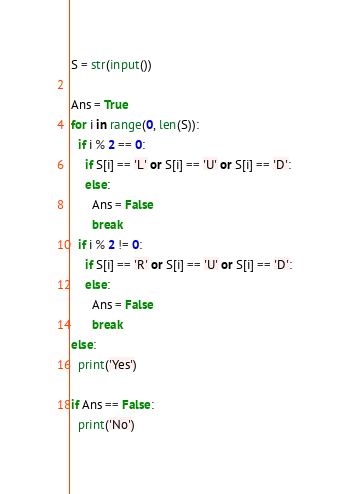<code> <loc_0><loc_0><loc_500><loc_500><_Python_>S = str(input())

Ans = True
for i in range(0, len(S)):
  if i % 2 == 0:
    if S[i] == 'L' or S[i] == 'U' or S[i] == 'D':
    else:
      Ans = False
      break
  if i % 2 != 0:
    if S[i] == 'R' or S[i] == 'U' or S[i] == 'D':
    else:
      Ans = False
      break
else:
  print('Yes')
  
if Ans == False:
  print('No')</code> 